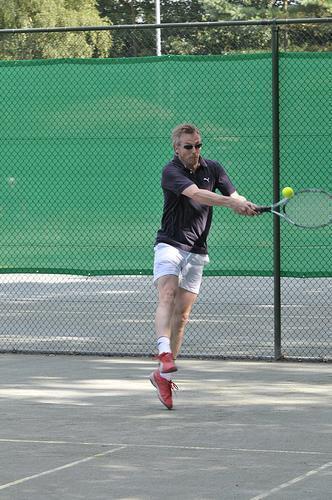Why does the man have his arms out?
Make your selection from the four choices given to correctly answer the question.
Options: Measure, break fall, to balance, to swing. To swing. 